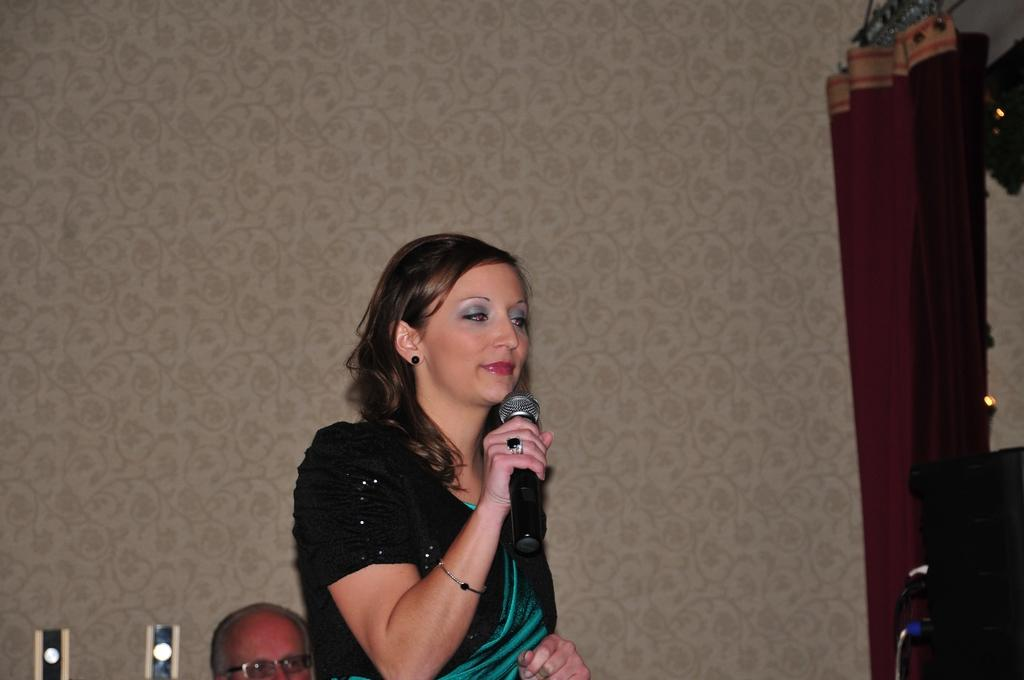Who is present in the image? There is a woman in the image. What is the woman doing in the image? The woman is standing and holding a microphone. What can be seen in the background of the image? There is a wall and a curtain in the image. What type of crime is being committed in the image? There is no crime being committed in the image; it features a woman standing and holding a microphone. What class of pets can be seen in the image? There are no pets present in the image. 